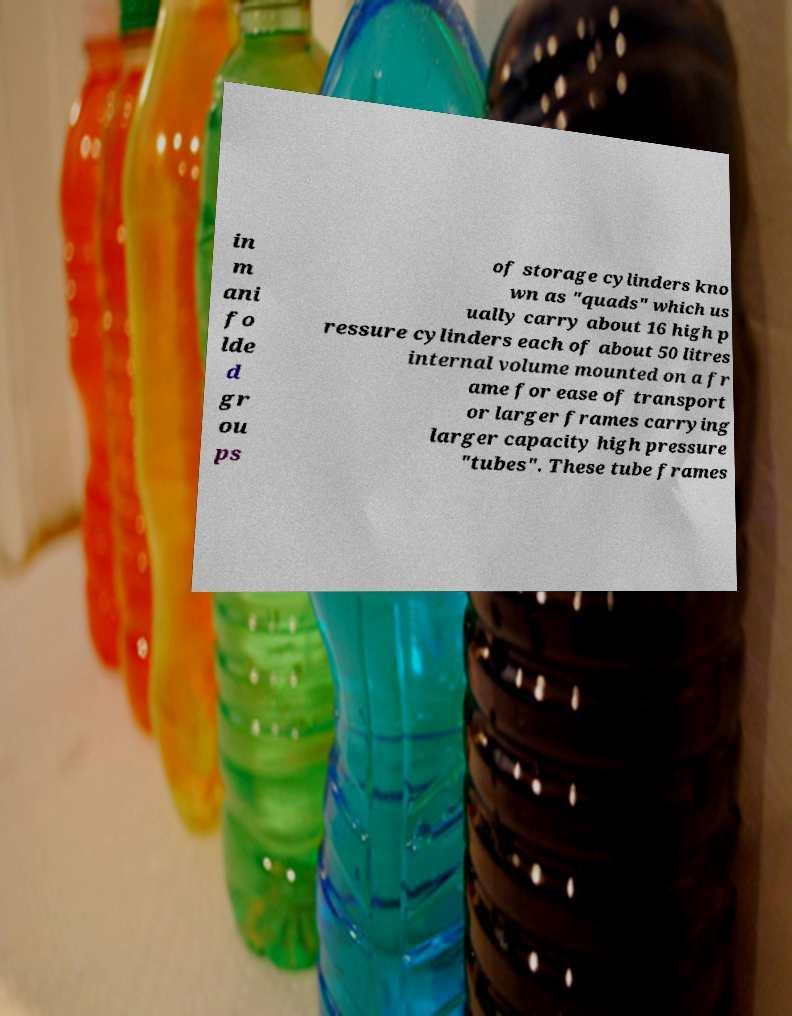Could you extract and type out the text from this image? in m ani fo lde d gr ou ps of storage cylinders kno wn as "quads" which us ually carry about 16 high p ressure cylinders each of about 50 litres internal volume mounted on a fr ame for ease of transport or larger frames carrying larger capacity high pressure "tubes". These tube frames 